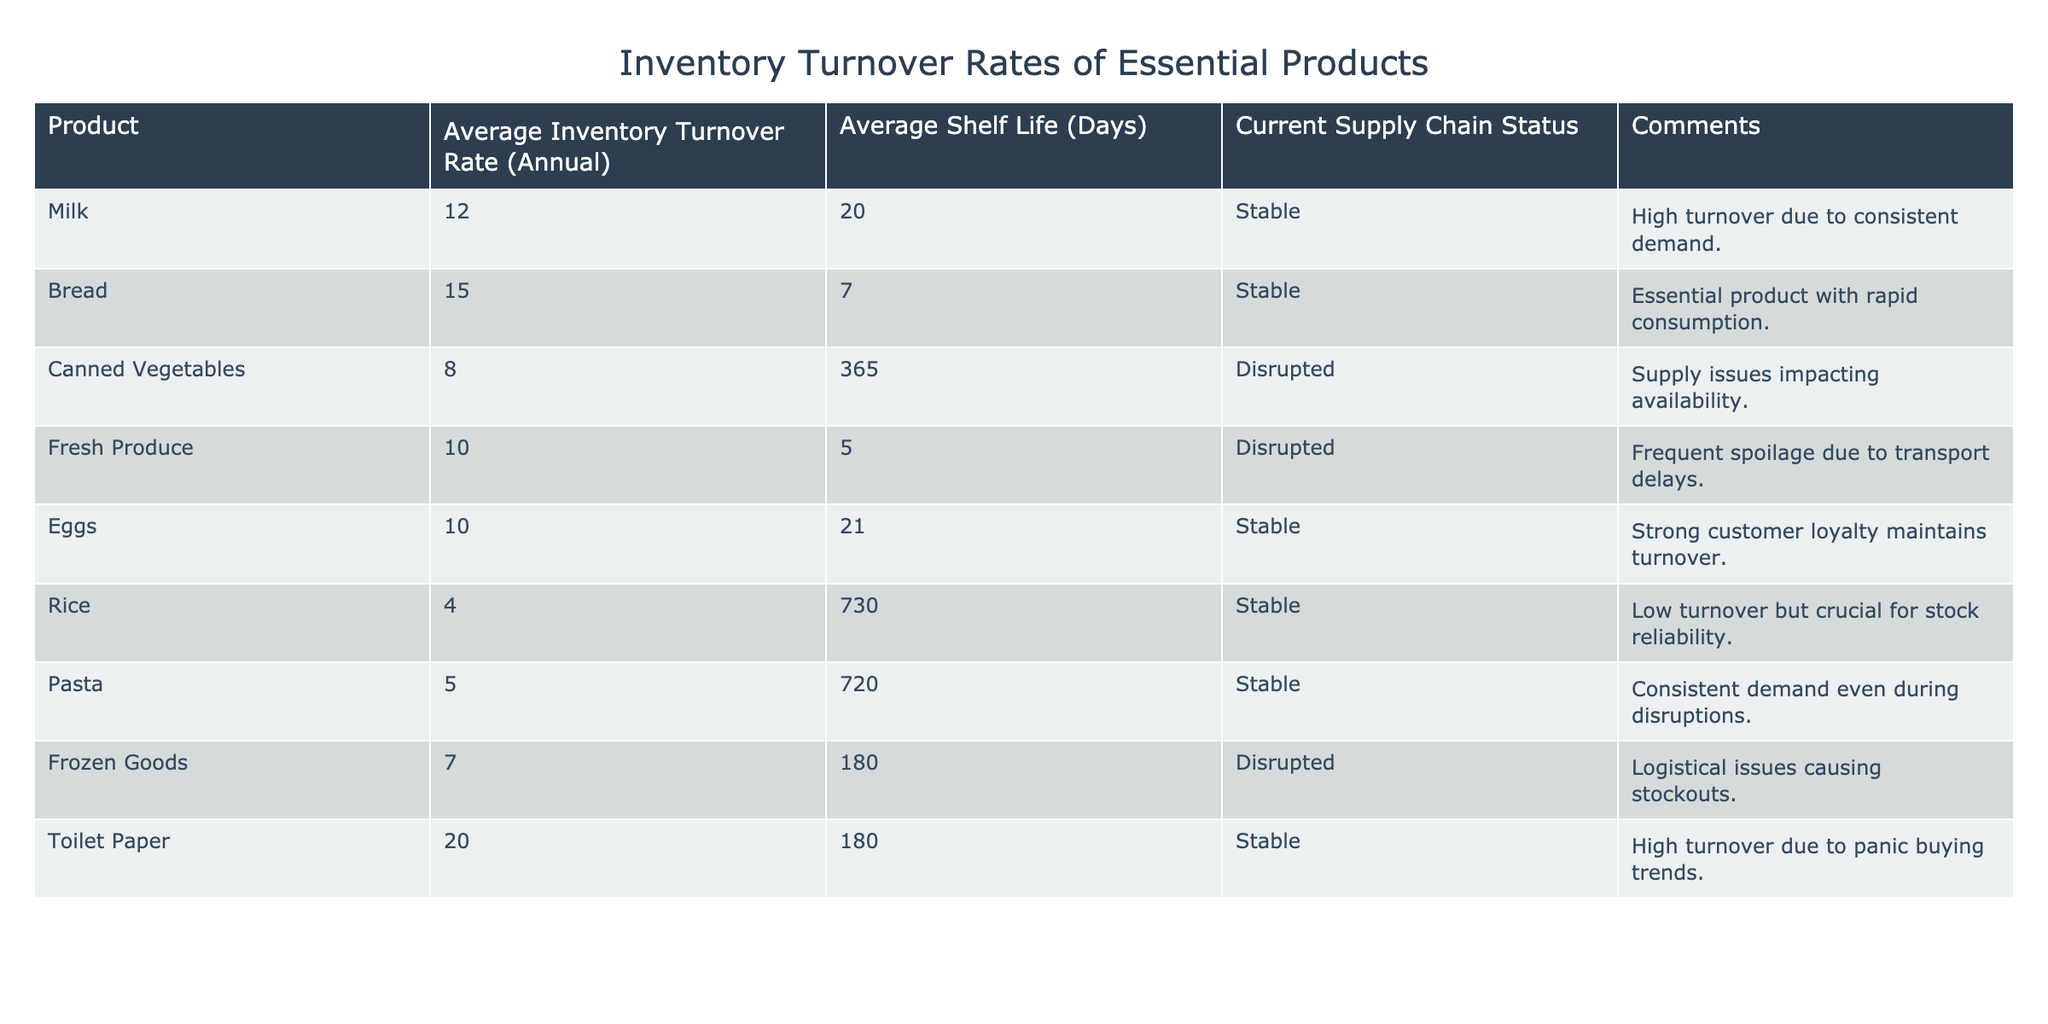What is the average inventory turnover rate for milk? The table lists the average inventory turnover rate for milk as 12.
Answer: 12 Which product has the highest inventory turnover rate? From the table, toilet paper has the highest turnover rate at 20.
Answer: 20 Are canned vegetables currently facing supply chain disruptions? Yes, the table indicates that the supply chain status for canned vegetables is disrupted.
Answer: Yes What is the average shelf life of bread? The table indicates that the average shelf life of bread is 7 days.
Answer: 7 days Which two products have a disrupted supply chain status and lower than the average turnover rate of 10? Fresh produce (10 turnover rate) and frozen goods (7 turnover rate) both have disrupted supply chain status and are below the average turnover rate of 10.
Answer: Fresh produce and frozen goods What is the total average inventory turnover rate for products with a stable supply chain status? The stable products are milk (12), bread (15), eggs (10), rice (4), pasta (5), and toilet paper (20). Their total turnover rate is (12 + 15 + 10 + 4 + 5 + 20) = 66.
Answer: 66 Does rice have a higher average inventory turnover rate than canned vegetables? No, rice has a turnover rate of 4, while canned vegetables have a turnover rate of 8, which is higher.
Answer: No What is the average shelf life of all products currently facing supply chain disruptions? Canned vegetables have a shelf life of 365 days, fresh produce 5 days, and frozen goods 180 days. The average is (365 + 5 + 180) / 3 = 183.33, rounded to 183 days.
Answer: 183 days Which essential product has both high turnover and a stable supply chain status? Toilet paper has a high turnover rate of 20 and a stable status, as indicated in the table.
Answer: Toilet paper 